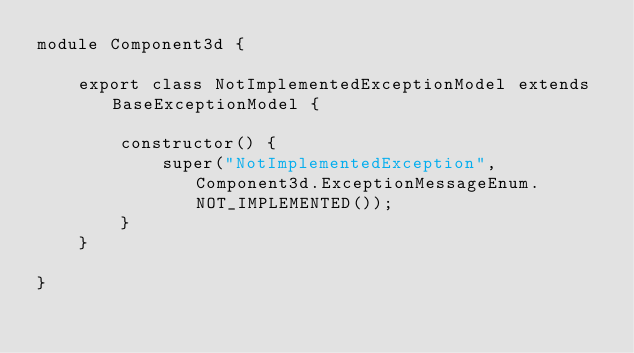Convert code to text. <code><loc_0><loc_0><loc_500><loc_500><_TypeScript_>module Component3d {

    export class NotImplementedExceptionModel extends BaseExceptionModel {

        constructor() {
            super("NotImplementedException", Component3d.ExceptionMessageEnum.NOT_IMPLEMENTED());
        }
    }

}</code> 